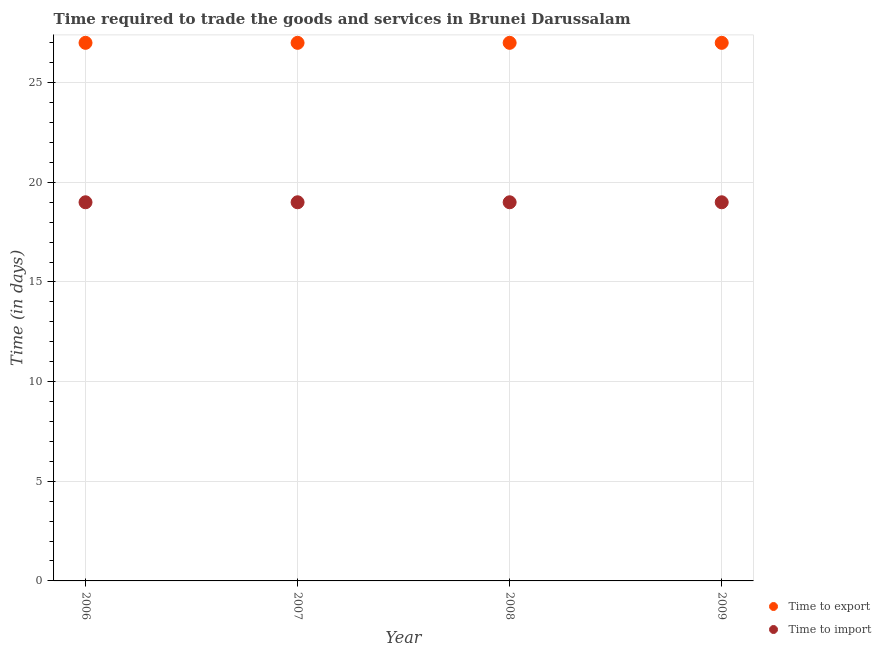How many different coloured dotlines are there?
Offer a terse response. 2. Is the number of dotlines equal to the number of legend labels?
Make the answer very short. Yes. What is the time to import in 2008?
Your answer should be very brief. 19. Across all years, what is the maximum time to import?
Offer a very short reply. 19. Across all years, what is the minimum time to export?
Provide a short and direct response. 27. What is the total time to import in the graph?
Keep it short and to the point. 76. What is the difference between the time to import in 2006 and that in 2009?
Ensure brevity in your answer.  0. What is the difference between the time to export in 2006 and the time to import in 2009?
Keep it short and to the point. 8. In the year 2006, what is the difference between the time to export and time to import?
Your answer should be compact. 8. How many dotlines are there?
Your response must be concise. 2. How many years are there in the graph?
Your answer should be compact. 4. What is the difference between two consecutive major ticks on the Y-axis?
Your response must be concise. 5. Are the values on the major ticks of Y-axis written in scientific E-notation?
Your answer should be compact. No. Does the graph contain any zero values?
Your response must be concise. No. Does the graph contain grids?
Your answer should be compact. Yes. How are the legend labels stacked?
Your answer should be compact. Vertical. What is the title of the graph?
Give a very brief answer. Time required to trade the goods and services in Brunei Darussalam. Does "Food" appear as one of the legend labels in the graph?
Ensure brevity in your answer.  No. What is the label or title of the X-axis?
Make the answer very short. Year. What is the label or title of the Y-axis?
Give a very brief answer. Time (in days). What is the Time (in days) of Time to export in 2006?
Offer a very short reply. 27. What is the Time (in days) of Time to export in 2007?
Provide a succinct answer. 27. What is the Time (in days) in Time to export in 2008?
Keep it short and to the point. 27. Across all years, what is the maximum Time (in days) of Time to export?
Give a very brief answer. 27. What is the total Time (in days) of Time to export in the graph?
Ensure brevity in your answer.  108. What is the difference between the Time (in days) of Time to export in 2006 and that in 2007?
Make the answer very short. 0. What is the difference between the Time (in days) of Time to import in 2006 and that in 2008?
Keep it short and to the point. 0. What is the difference between the Time (in days) in Time to export in 2006 and that in 2009?
Provide a short and direct response. 0. What is the difference between the Time (in days) of Time to import in 2006 and that in 2009?
Your answer should be compact. 0. What is the difference between the Time (in days) of Time to export in 2007 and that in 2008?
Your response must be concise. 0. What is the difference between the Time (in days) in Time to export in 2007 and that in 2009?
Your answer should be compact. 0. What is the difference between the Time (in days) of Time to import in 2007 and that in 2009?
Provide a succinct answer. 0. What is the difference between the Time (in days) of Time to export in 2008 and that in 2009?
Offer a very short reply. 0. What is the difference between the Time (in days) of Time to export in 2007 and the Time (in days) of Time to import in 2008?
Your response must be concise. 8. What is the difference between the Time (in days) of Time to export in 2008 and the Time (in days) of Time to import in 2009?
Provide a short and direct response. 8. In the year 2006, what is the difference between the Time (in days) in Time to export and Time (in days) in Time to import?
Provide a succinct answer. 8. In the year 2008, what is the difference between the Time (in days) of Time to export and Time (in days) of Time to import?
Ensure brevity in your answer.  8. In the year 2009, what is the difference between the Time (in days) of Time to export and Time (in days) of Time to import?
Keep it short and to the point. 8. What is the ratio of the Time (in days) of Time to export in 2006 to that in 2007?
Keep it short and to the point. 1. What is the ratio of the Time (in days) in Time to import in 2006 to that in 2007?
Your answer should be compact. 1. What is the ratio of the Time (in days) of Time to export in 2006 to that in 2008?
Provide a succinct answer. 1. What is the ratio of the Time (in days) of Time to import in 2006 to that in 2008?
Provide a succinct answer. 1. What is the ratio of the Time (in days) of Time to export in 2006 to that in 2009?
Provide a short and direct response. 1. What is the ratio of the Time (in days) of Time to import in 2006 to that in 2009?
Offer a very short reply. 1. What is the ratio of the Time (in days) in Time to export in 2007 to that in 2008?
Offer a terse response. 1. What is the ratio of the Time (in days) of Time to import in 2007 to that in 2008?
Offer a terse response. 1. What is the ratio of the Time (in days) of Time to import in 2007 to that in 2009?
Offer a very short reply. 1. What is the ratio of the Time (in days) in Time to export in 2008 to that in 2009?
Make the answer very short. 1. What is the ratio of the Time (in days) of Time to import in 2008 to that in 2009?
Your answer should be very brief. 1. What is the difference between the highest and the second highest Time (in days) in Time to import?
Ensure brevity in your answer.  0. What is the difference between the highest and the lowest Time (in days) in Time to export?
Offer a terse response. 0. 